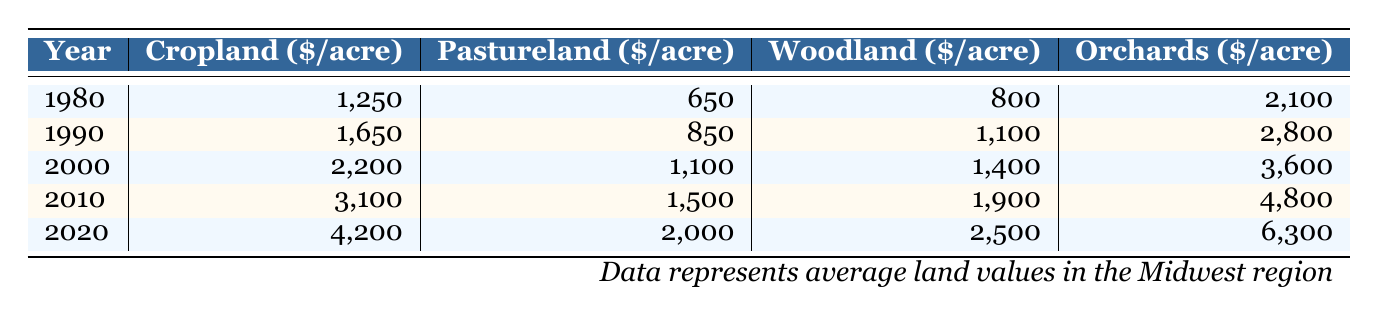What was the value of cropland per acre in 2010? According to the table, in the year 2010, the value of cropland was listed as 3,100 dollars per acre.
Answer: 3,100 What is the highest recorded value for pastureland in the provided years? To find the highest value for pastureland, we can look at the values from each year: 650, 850, 1,100, 1,500, and 2,000 dollars per acre. The highest among these values is 2,000 dollars per acre, recorded in 2020.
Answer: 2,000 How much more is the value of orchards in 2020 compared to 1980? The value of orchards in 2020 is 6,300 dollars per acre, while in 1980 it was 2,100 dollars per acre. To find the difference, we subtract: 6,300 - 2,100 = 4,200 dollars per acre.
Answer: 4,200 Is the value of woodland in 1990 greater than that in 2000? The table shows that the value of woodland in 1990 is 1,100 dollars per acre and in 2000 it is 1,400 dollars per acre. Since 1,100 is less than 1,400, the statement is false.
Answer: No What is the average value of cropland across all the years? The values for cropland are 1,250, 1,650, 2,200, 3,100, and 4,200 dollars per acre. To calculate the average, we first sum these values: 1,250 + 1,650 + 2,200 + 3,100 + 4,200 = 12,400. There are 5 years, so the average is 12,400/5 = 2,480 dollars per acre.
Answer: 2,480 Which type of land had the least increase in value from 1980 to 2020? To determine this, we compare the increases for each type of land: Cropland (4,200 - 1,250 = 2,950), Pastureland (2,000 - 650 = 1,350), Woodland (2,500 - 800 = 1,700), and Orchards (6,300 - 2,100 = 4,200). The smallest increase is for Pastureland, with an increase of 1,350 dollars per acre.
Answer: Pastureland What year saw the lowest average value for all types of land combined? To find this, we can look at the values of each type of land for each year and calculate the average for each year. In 1980, the average is (1,250 + 650 + 800 + 2,100) / 4 = 965 dollars per acre. For 1990, it is (1,650 + 850 + 1,100 + 2,800) / 4 = 1,350 dollars per acre, and so on. The year with the lowest average is 1980.
Answer: 1980 